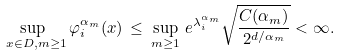<formula> <loc_0><loc_0><loc_500><loc_500>\sup _ { \ x \in D , m \geq 1 } \varphi ^ { \alpha _ { m } } _ { i } ( x ) \, \leq \, \sup _ { m \geq 1 } \, e ^ { \lambda ^ { \alpha _ { m } } _ { i } } \sqrt { \frac { C ( \alpha _ { m } ) } { 2 ^ { d / \alpha _ { m } } } } < \infty .</formula> 